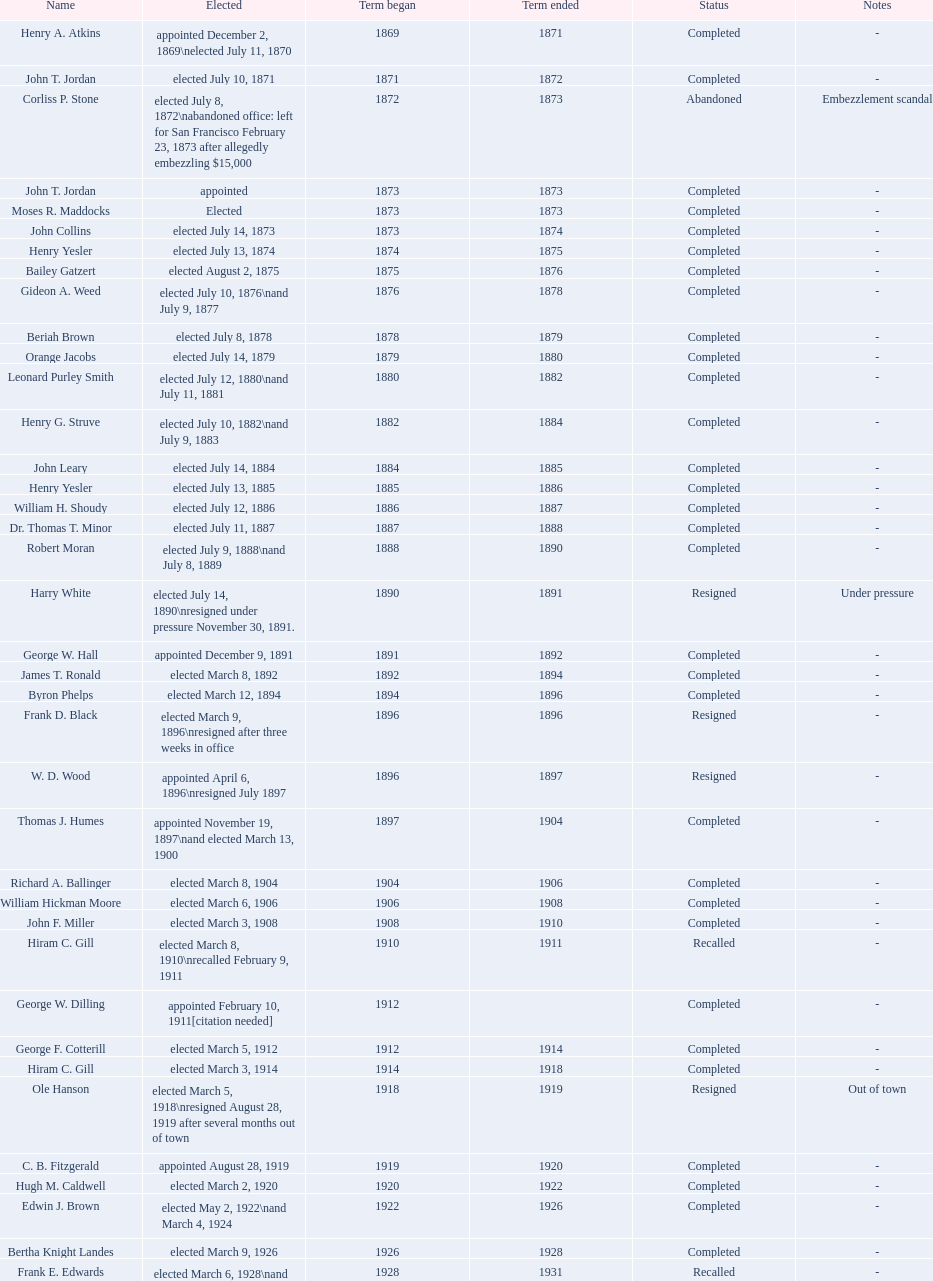Who held the position of the first mayor in the 20th century? Richard A. Ballinger. 